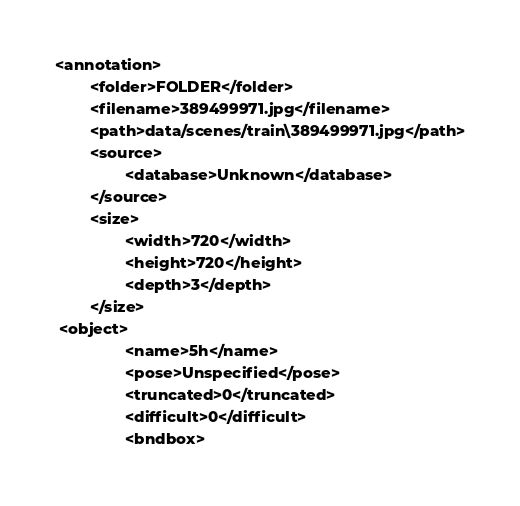Convert code to text. <code><loc_0><loc_0><loc_500><loc_500><_XML_><annotation>
        <folder>FOLDER</folder>
        <filename>389499971.jpg</filename>
        <path>data/scenes/train\389499971.jpg</path>
        <source>
                <database>Unknown</database>
        </source>
        <size>
                <width>720</width>
                <height>720</height>
                <depth>3</depth>
        </size>
 <object>
                <name>5h</name>
                <pose>Unspecified</pose>
                <truncated>0</truncated>
                <difficult>0</difficult>
                <bndbox></code> 